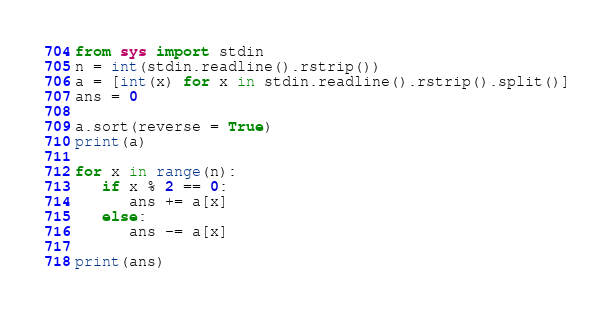Convert code to text. <code><loc_0><loc_0><loc_500><loc_500><_Python_>from sys import stdin
n = int(stdin.readline().rstrip())
a = [int(x) for x in stdin.readline().rstrip().split()]
ans = 0

a.sort(reverse = True)
print(a)

for x in range(n):
   if x % 2 == 0:
      ans += a[x]
   else:
      ans -= a[x]

print(ans)</code> 